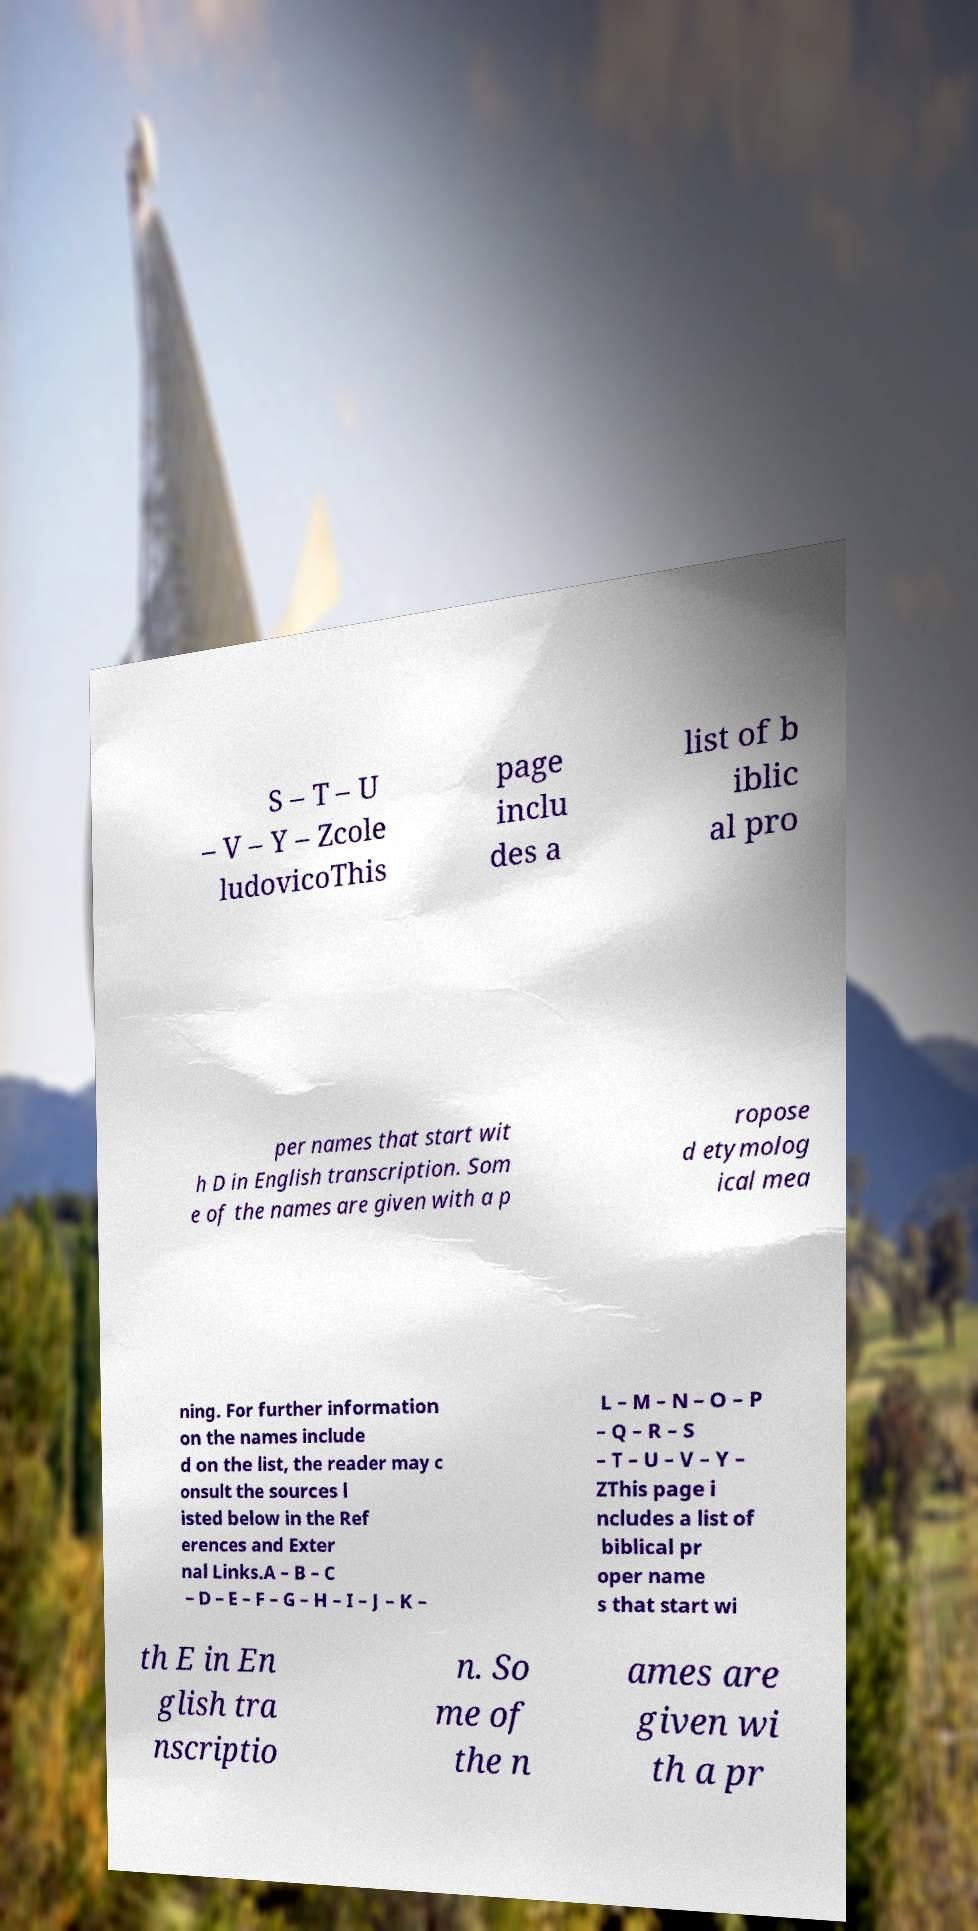Could you extract and type out the text from this image? S – T – U – V – Y – Zcole ludovicoThis page inclu des a list of b iblic al pro per names that start wit h D in English transcription. Som e of the names are given with a p ropose d etymolog ical mea ning. For further information on the names include d on the list, the reader may c onsult the sources l isted below in the Ref erences and Exter nal Links.A – B – C – D – E – F – G – H – I – J – K – L – M – N – O – P – Q – R – S – T – U – V – Y – ZThis page i ncludes a list of biblical pr oper name s that start wi th E in En glish tra nscriptio n. So me of the n ames are given wi th a pr 